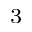<formula> <loc_0><loc_0><loc_500><loc_500>^ { 3 }</formula> 